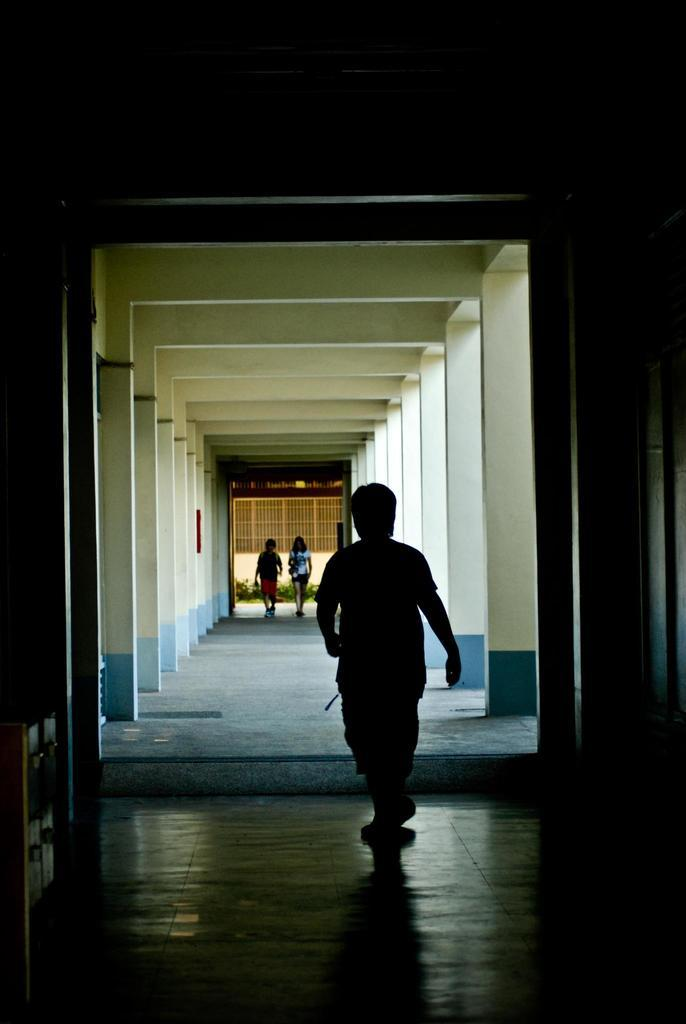What are the three persons in the image doing? The three persons are walking in the image. What can be seen in the background of the image? There are plants and grilles in the background of the image. Where is the image taken? The image is an inside view of a building. What is the weight of the porter carrying a heavy load in the image? There is no porter carrying a heavy load in the image; it only shows three persons walking. How many slaves are visible in the image? There are no slaves present in the image; it only shows three persons walking. 